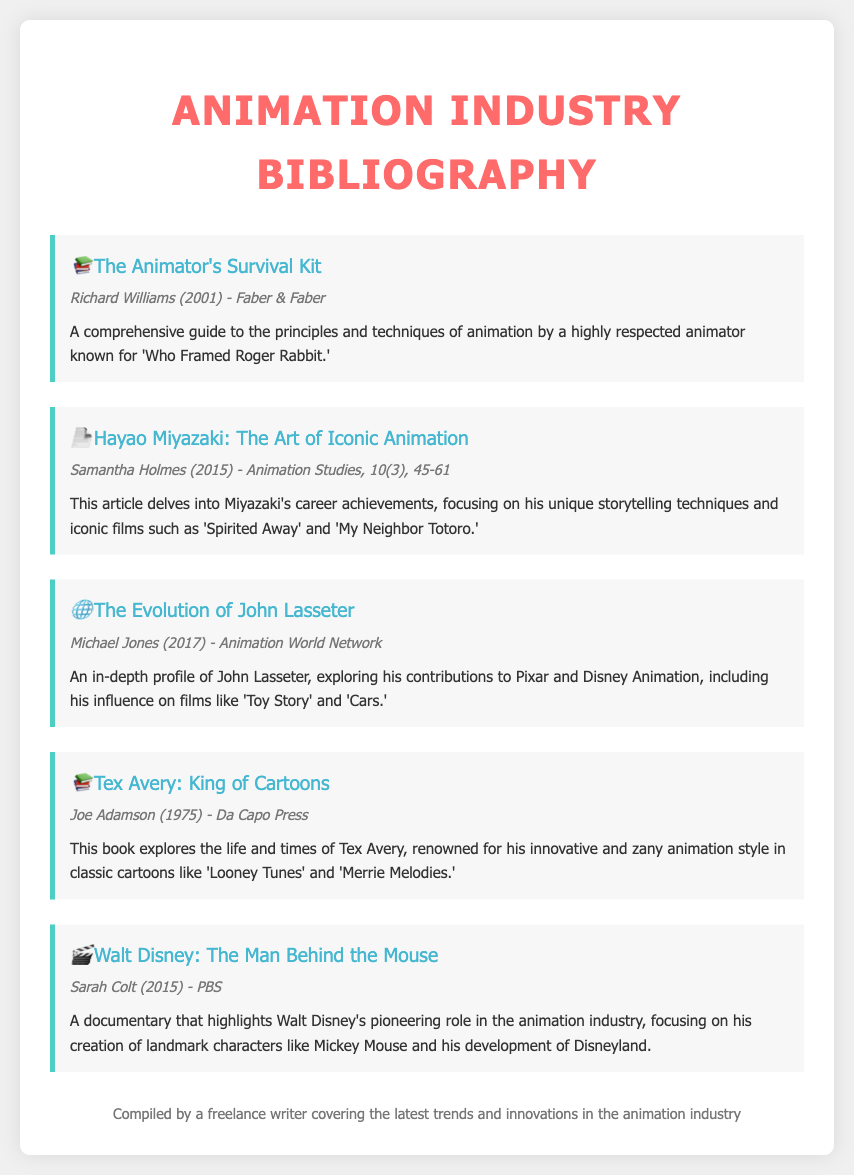What is the title of Richard Williams' work? The title is explicitly mentioned in the document as "The Animator's Survival Kit."
Answer: The Animator's Survival Kit Who is the author of the article about Hayao Miyazaki? The document lists Samantha Holmes as the author of this article.
Answer: Samantha Holmes In what year was "Tex Avery: King of Cartoons" published? The publication year for this work is provided as 1975 in the entry.
Answer: 1975 Which animator is known for "Toy Story" and "Cars"? The document points out John Lasseter as the animator associated with these films.
Answer: John Lasseter What type of media is "Walt Disney: The Man Behind the Mouse"? The document categorizes this as a documentary.
Answer: Documentary What is a notable feature of Tex Avery's animation style? It is referred to as innovative and zany in the document.
Answer: Innovative and zany What is the focus of the article by Michael Jones? The article emphasizes John Lasseter's contributions to Pixar and Disney animation.
Answer: John Lasseter's contributions Which character is mentioned as being created by Walt Disney? The document states Mickey Mouse as one of the landmark characters created by Walt Disney.
Answer: Mickey Mouse What publisher released "The Animator's Survival Kit"? The document specifies Faber & Faber as the publisher for this work.
Answer: Faber & Faber 